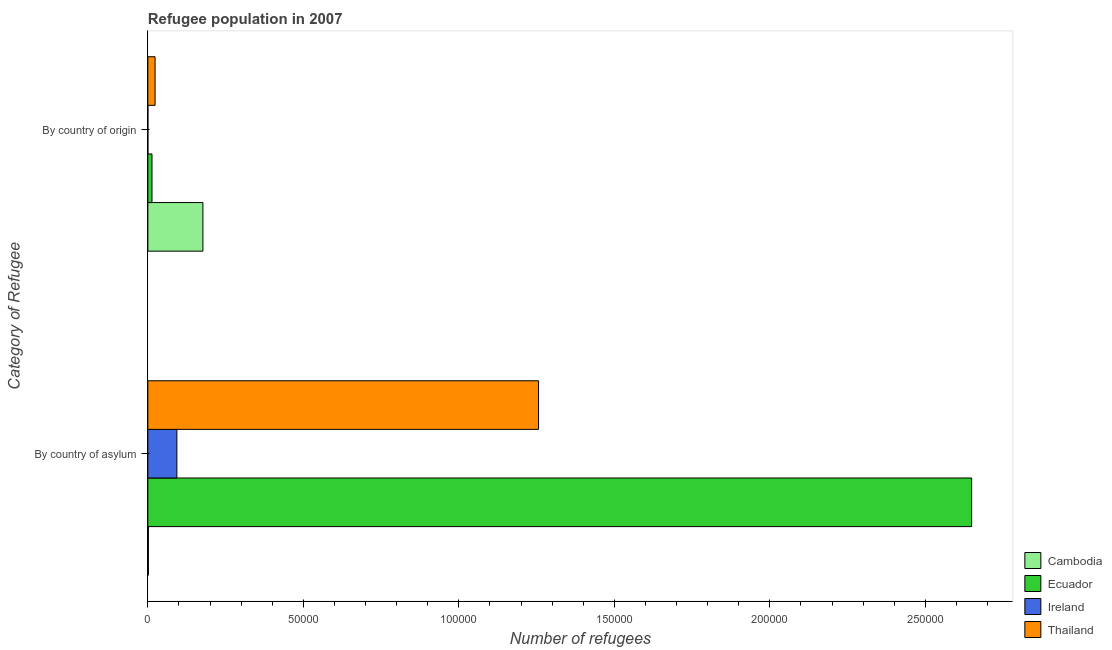How many groups of bars are there?
Ensure brevity in your answer.  2. Are the number of bars on each tick of the Y-axis equal?
Offer a very short reply. Yes. How many bars are there on the 1st tick from the top?
Keep it short and to the point. 4. How many bars are there on the 1st tick from the bottom?
Offer a terse response. 4. What is the label of the 2nd group of bars from the top?
Provide a short and direct response. By country of asylum. What is the number of refugees by country of origin in Thailand?
Offer a very short reply. 2325. Across all countries, what is the maximum number of refugees by country of origin?
Provide a succinct answer. 1.77e+04. Across all countries, what is the minimum number of refugees by country of origin?
Ensure brevity in your answer.  10. In which country was the number of refugees by country of origin maximum?
Your answer should be compact. Cambodia. In which country was the number of refugees by country of origin minimum?
Your answer should be very brief. Ireland. What is the total number of refugees by country of asylum in the graph?
Offer a terse response. 4.00e+05. What is the difference between the number of refugees by country of asylum in Ireland and that in Cambodia?
Ensure brevity in your answer.  9154. What is the difference between the number of refugees by country of asylum in Ecuador and the number of refugees by country of origin in Ireland?
Your answer should be compact. 2.65e+05. What is the average number of refugees by country of origin per country?
Offer a terse response. 5342.75. What is the difference between the number of refugees by country of asylum and number of refugees by country of origin in Ireland?
Ensure brevity in your answer.  9323. What is the ratio of the number of refugees by country of asylum in Ecuador to that in Ireland?
Offer a terse response. 28.38. What does the 4th bar from the top in By country of asylum represents?
Ensure brevity in your answer.  Cambodia. What does the 1st bar from the bottom in By country of origin represents?
Provide a succinct answer. Cambodia. How many bars are there?
Provide a succinct answer. 8. Are the values on the major ticks of X-axis written in scientific E-notation?
Your answer should be very brief. No. Does the graph contain grids?
Your answer should be compact. No. Where does the legend appear in the graph?
Make the answer very short. Bottom right. How many legend labels are there?
Your answer should be very brief. 4. How are the legend labels stacked?
Give a very brief answer. Vertical. What is the title of the graph?
Offer a very short reply. Refugee population in 2007. Does "Timor-Leste" appear as one of the legend labels in the graph?
Provide a short and direct response. No. What is the label or title of the X-axis?
Offer a terse response. Number of refugees. What is the label or title of the Y-axis?
Provide a short and direct response. Category of Refugee. What is the Number of refugees of Cambodia in By country of asylum?
Keep it short and to the point. 179. What is the Number of refugees of Ecuador in By country of asylum?
Your response must be concise. 2.65e+05. What is the Number of refugees of Ireland in By country of asylum?
Make the answer very short. 9333. What is the Number of refugees of Thailand in By country of asylum?
Ensure brevity in your answer.  1.26e+05. What is the Number of refugees in Cambodia in By country of origin?
Offer a terse response. 1.77e+04. What is the Number of refugees in Ecuador in By country of origin?
Your answer should be very brief. 1332. What is the Number of refugees of Thailand in By country of origin?
Make the answer very short. 2325. Across all Category of Refugee, what is the maximum Number of refugees in Cambodia?
Provide a succinct answer. 1.77e+04. Across all Category of Refugee, what is the maximum Number of refugees of Ecuador?
Offer a very short reply. 2.65e+05. Across all Category of Refugee, what is the maximum Number of refugees in Ireland?
Offer a terse response. 9333. Across all Category of Refugee, what is the maximum Number of refugees of Thailand?
Provide a short and direct response. 1.26e+05. Across all Category of Refugee, what is the minimum Number of refugees of Cambodia?
Give a very brief answer. 179. Across all Category of Refugee, what is the minimum Number of refugees in Ecuador?
Your answer should be compact. 1332. Across all Category of Refugee, what is the minimum Number of refugees of Ireland?
Provide a short and direct response. 10. Across all Category of Refugee, what is the minimum Number of refugees in Thailand?
Keep it short and to the point. 2325. What is the total Number of refugees in Cambodia in the graph?
Offer a very short reply. 1.79e+04. What is the total Number of refugees of Ecuador in the graph?
Keep it short and to the point. 2.66e+05. What is the total Number of refugees in Ireland in the graph?
Your answer should be very brief. 9343. What is the total Number of refugees of Thailand in the graph?
Provide a succinct answer. 1.28e+05. What is the difference between the Number of refugees in Cambodia in By country of asylum and that in By country of origin?
Ensure brevity in your answer.  -1.75e+04. What is the difference between the Number of refugees in Ecuador in By country of asylum and that in By country of origin?
Provide a succinct answer. 2.64e+05. What is the difference between the Number of refugees in Ireland in By country of asylum and that in By country of origin?
Your answer should be very brief. 9323. What is the difference between the Number of refugees of Thailand in By country of asylum and that in By country of origin?
Keep it short and to the point. 1.23e+05. What is the difference between the Number of refugees of Cambodia in By country of asylum and the Number of refugees of Ecuador in By country of origin?
Ensure brevity in your answer.  -1153. What is the difference between the Number of refugees of Cambodia in By country of asylum and the Number of refugees of Ireland in By country of origin?
Provide a short and direct response. 169. What is the difference between the Number of refugees in Cambodia in By country of asylum and the Number of refugees in Thailand in By country of origin?
Keep it short and to the point. -2146. What is the difference between the Number of refugees in Ecuador in By country of asylum and the Number of refugees in Ireland in By country of origin?
Ensure brevity in your answer.  2.65e+05. What is the difference between the Number of refugees in Ecuador in By country of asylum and the Number of refugees in Thailand in By country of origin?
Your answer should be very brief. 2.63e+05. What is the difference between the Number of refugees of Ireland in By country of asylum and the Number of refugees of Thailand in By country of origin?
Your answer should be very brief. 7008. What is the average Number of refugees of Cambodia per Category of Refugee?
Your answer should be very brief. 8941.5. What is the average Number of refugees of Ecuador per Category of Refugee?
Your answer should be very brief. 1.33e+05. What is the average Number of refugees in Ireland per Category of Refugee?
Make the answer very short. 4671.5. What is the average Number of refugees of Thailand per Category of Refugee?
Keep it short and to the point. 6.40e+04. What is the difference between the Number of refugees of Cambodia and Number of refugees of Ecuador in By country of asylum?
Make the answer very short. -2.65e+05. What is the difference between the Number of refugees in Cambodia and Number of refugees in Ireland in By country of asylum?
Your response must be concise. -9154. What is the difference between the Number of refugees in Cambodia and Number of refugees in Thailand in By country of asylum?
Provide a succinct answer. -1.25e+05. What is the difference between the Number of refugees of Ecuador and Number of refugees of Ireland in By country of asylum?
Your answer should be compact. 2.56e+05. What is the difference between the Number of refugees in Ecuador and Number of refugees in Thailand in By country of asylum?
Keep it short and to the point. 1.39e+05. What is the difference between the Number of refugees in Ireland and Number of refugees in Thailand in By country of asylum?
Your answer should be compact. -1.16e+05. What is the difference between the Number of refugees in Cambodia and Number of refugees in Ecuador in By country of origin?
Provide a succinct answer. 1.64e+04. What is the difference between the Number of refugees in Cambodia and Number of refugees in Ireland in By country of origin?
Provide a succinct answer. 1.77e+04. What is the difference between the Number of refugees of Cambodia and Number of refugees of Thailand in By country of origin?
Your answer should be very brief. 1.54e+04. What is the difference between the Number of refugees in Ecuador and Number of refugees in Ireland in By country of origin?
Give a very brief answer. 1322. What is the difference between the Number of refugees in Ecuador and Number of refugees in Thailand in By country of origin?
Your answer should be compact. -993. What is the difference between the Number of refugees of Ireland and Number of refugees of Thailand in By country of origin?
Offer a very short reply. -2315. What is the ratio of the Number of refugees in Cambodia in By country of asylum to that in By country of origin?
Give a very brief answer. 0.01. What is the ratio of the Number of refugees of Ecuador in By country of asylum to that in By country of origin?
Your answer should be very brief. 198.88. What is the ratio of the Number of refugees of Ireland in By country of asylum to that in By country of origin?
Keep it short and to the point. 933.3. What is the ratio of the Number of refugees in Thailand in By country of asylum to that in By country of origin?
Offer a terse response. 54.04. What is the difference between the highest and the second highest Number of refugees of Cambodia?
Keep it short and to the point. 1.75e+04. What is the difference between the highest and the second highest Number of refugees of Ecuador?
Provide a short and direct response. 2.64e+05. What is the difference between the highest and the second highest Number of refugees in Ireland?
Make the answer very short. 9323. What is the difference between the highest and the second highest Number of refugees in Thailand?
Keep it short and to the point. 1.23e+05. What is the difference between the highest and the lowest Number of refugees of Cambodia?
Offer a terse response. 1.75e+04. What is the difference between the highest and the lowest Number of refugees in Ecuador?
Give a very brief answer. 2.64e+05. What is the difference between the highest and the lowest Number of refugees of Ireland?
Make the answer very short. 9323. What is the difference between the highest and the lowest Number of refugees in Thailand?
Offer a terse response. 1.23e+05. 